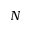Convert formula to latex. <formula><loc_0><loc_0><loc_500><loc_500>N</formula> 